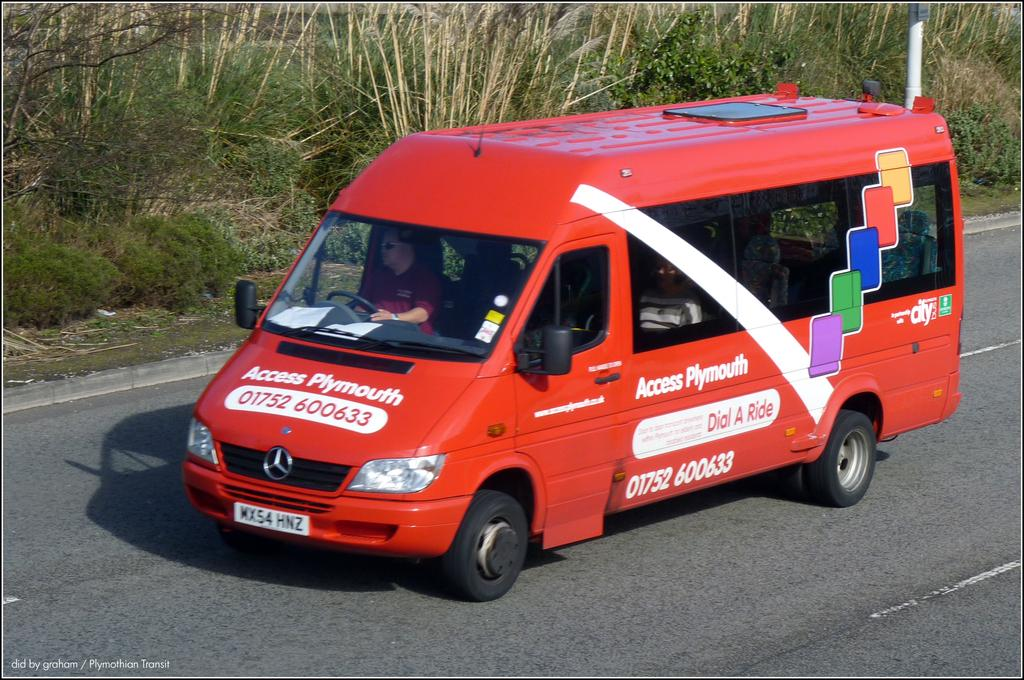What is the person in the image doing? The person is in a bus in the image. Where is the bus located? The bus is on the road. What can be seen in the background of the image? There are trees, plants, and a pole in the background of the image. What advice is the person in the bus giving to the bikes in the image? There are no bikes present in the image, so the person cannot give advice to them. 